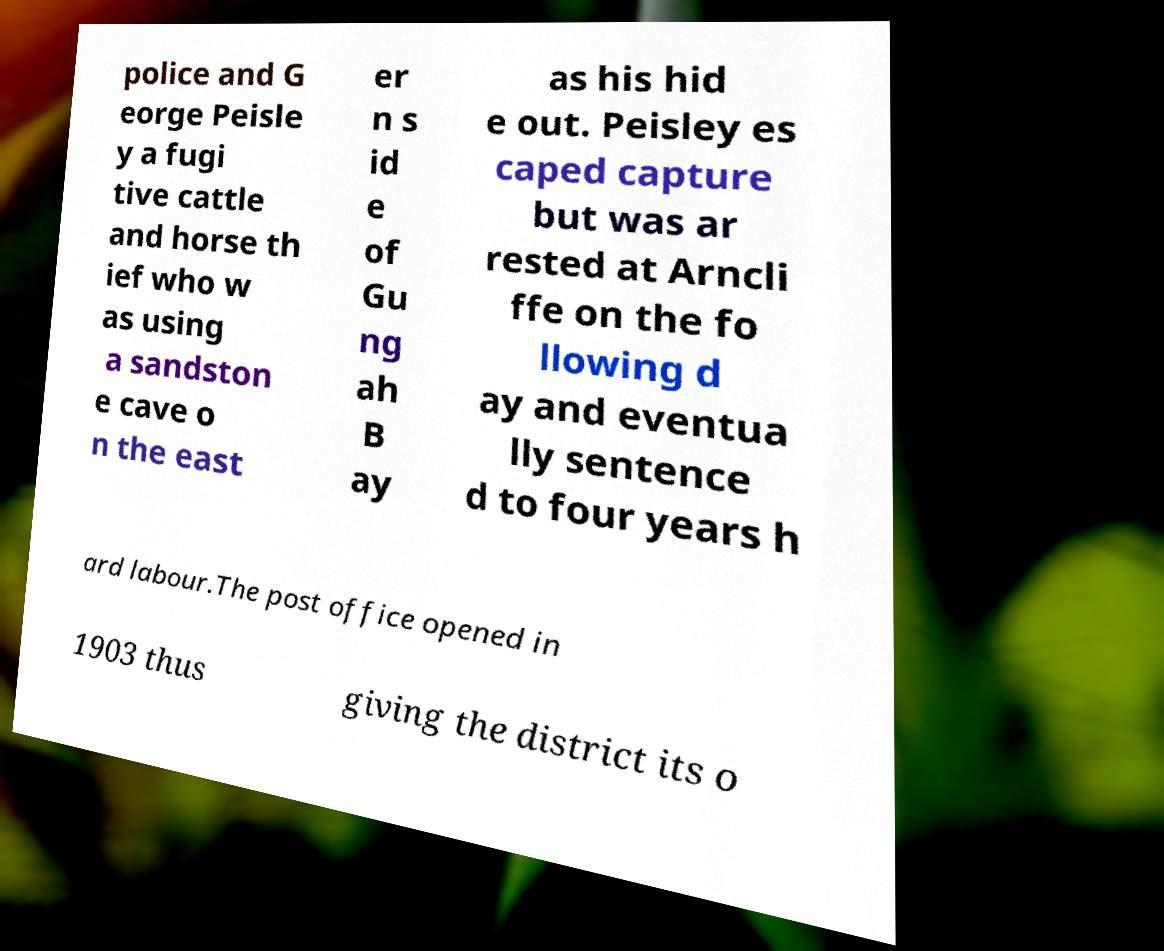Can you accurately transcribe the text from the provided image for me? police and G eorge Peisle y a fugi tive cattle and horse th ief who w as using a sandston e cave o n the east er n s id e of Gu ng ah B ay as his hid e out. Peisley es caped capture but was ar rested at Arncli ffe on the fo llowing d ay and eventua lly sentence d to four years h ard labour.The post office opened in 1903 thus giving the district its o 